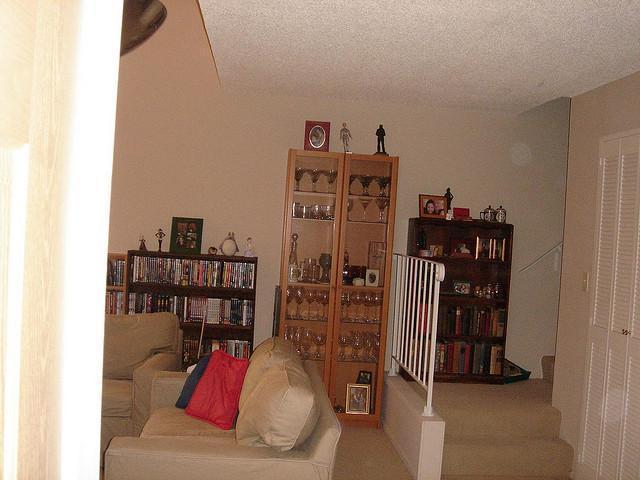How many books can you see?
Give a very brief answer. 2. How many couches are in the photo?
Give a very brief answer. 2. 